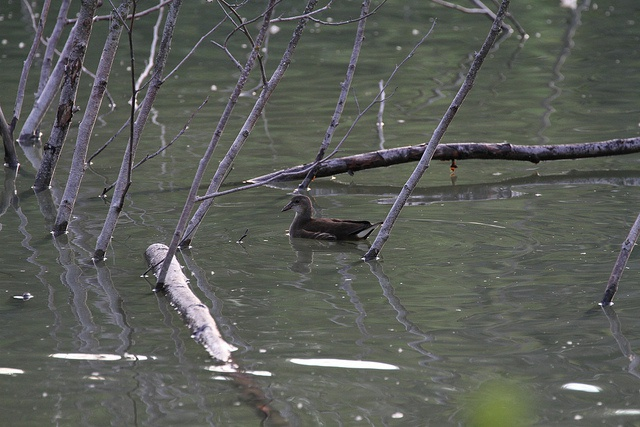Describe the objects in this image and their specific colors. I can see a bird in black and gray tones in this image. 